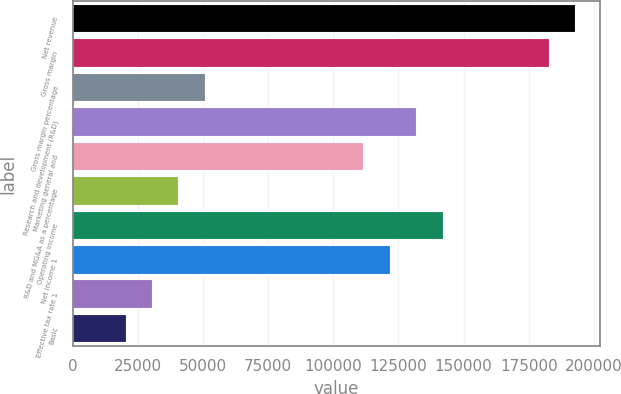Convert chart. <chart><loc_0><loc_0><loc_500><loc_500><bar_chart><fcel>Net revenue<fcel>Gross margin<fcel>Gross margin percentage<fcel>Research and development (R&D)<fcel>Marketing general and<fcel>R&D and MG&A as a percentage<fcel>Operating income<fcel>Net income 1<fcel>Effective tax rate 1<fcel>Basic<nl><fcel>192771<fcel>182625<fcel>50730<fcel>131896<fcel>111605<fcel>40584.2<fcel>142042<fcel>121751<fcel>30438.4<fcel>20292.6<nl></chart> 